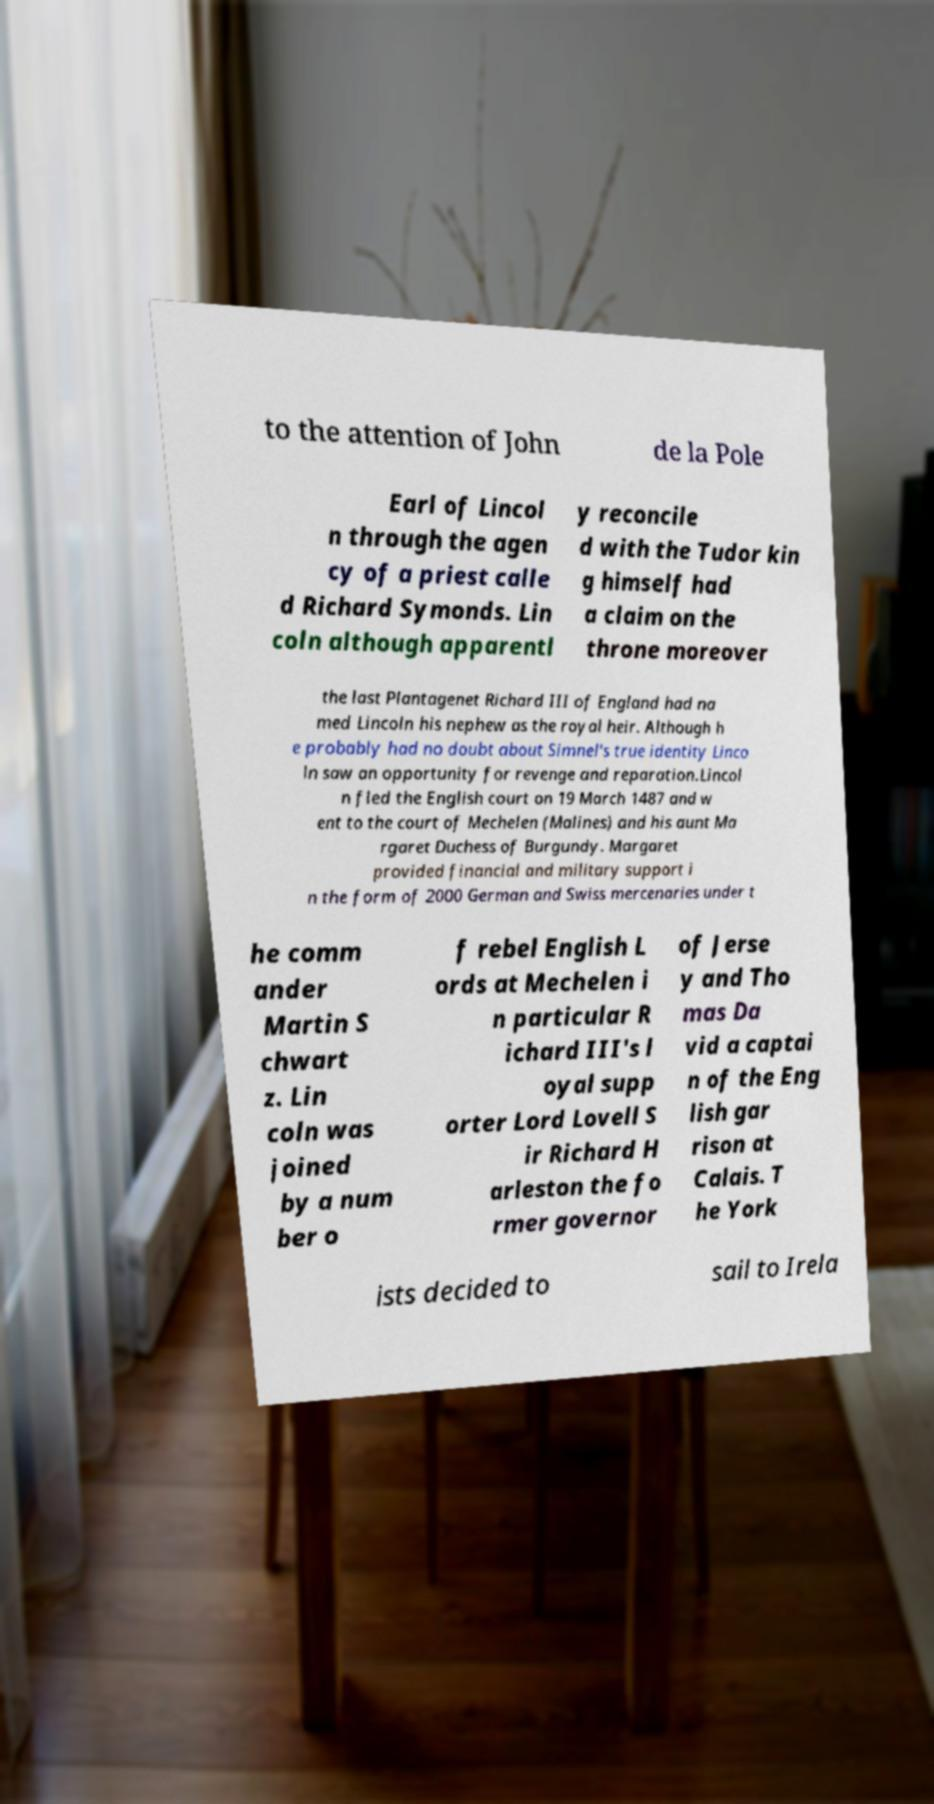For documentation purposes, I need the text within this image transcribed. Could you provide that? to the attention of John de la Pole Earl of Lincol n through the agen cy of a priest calle d Richard Symonds. Lin coln although apparentl y reconcile d with the Tudor kin g himself had a claim on the throne moreover the last Plantagenet Richard III of England had na med Lincoln his nephew as the royal heir. Although h e probably had no doubt about Simnel's true identity Linco ln saw an opportunity for revenge and reparation.Lincol n fled the English court on 19 March 1487 and w ent to the court of Mechelen (Malines) and his aunt Ma rgaret Duchess of Burgundy. Margaret provided financial and military support i n the form of 2000 German and Swiss mercenaries under t he comm ander Martin S chwart z. Lin coln was joined by a num ber o f rebel English L ords at Mechelen i n particular R ichard III's l oyal supp orter Lord Lovell S ir Richard H arleston the fo rmer governor of Jerse y and Tho mas Da vid a captai n of the Eng lish gar rison at Calais. T he York ists decided to sail to Irela 